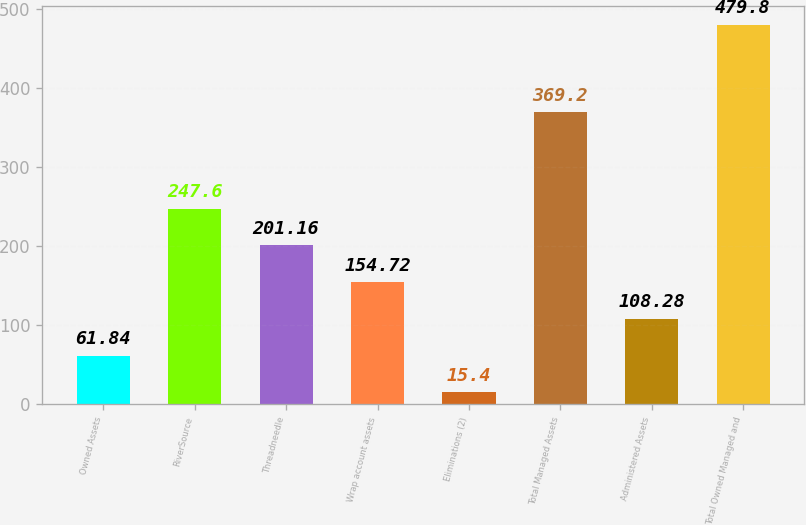Convert chart to OTSL. <chart><loc_0><loc_0><loc_500><loc_500><bar_chart><fcel>Owned Assets<fcel>RiverSource<fcel>Threadneedle<fcel>Wrap account assets<fcel>Eliminations (2)<fcel>Total Managed Assets<fcel>Administered Assets<fcel>Total Owned Managed and<nl><fcel>61.84<fcel>247.6<fcel>201.16<fcel>154.72<fcel>15.4<fcel>369.2<fcel>108.28<fcel>479.8<nl></chart> 